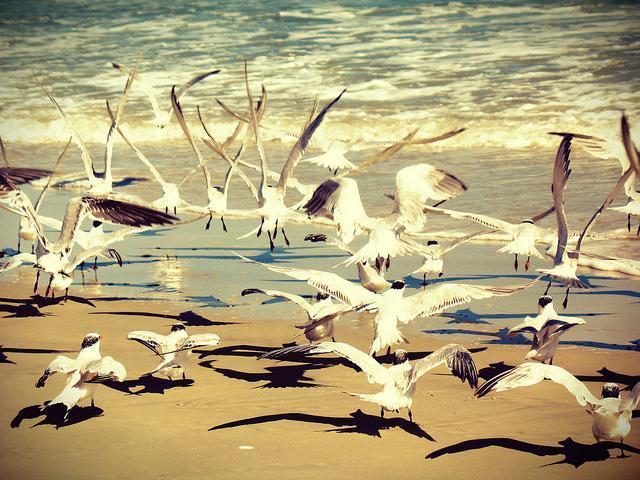How many birds can be seen?
Give a very brief answer. 12. 